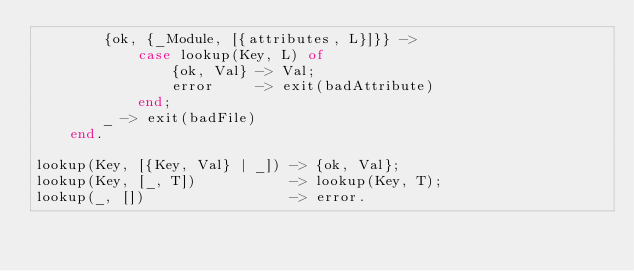Convert code to text. <code><loc_0><loc_0><loc_500><loc_500><_Erlang_>        {ok, {_Module, [{attributes, L}]}} ->
            case lookup(Key, L) of
                {ok, Val} -> Val;
                error     -> exit(badAttribute)
            end;
        _ -> exit(badFile)
    end.

lookup(Key, [{Key, Val} | _]) -> {ok, Val};
lookup(Key, [_, T])           -> lookup(Key, T);
lookup(_, [])                 -> error.

</code> 